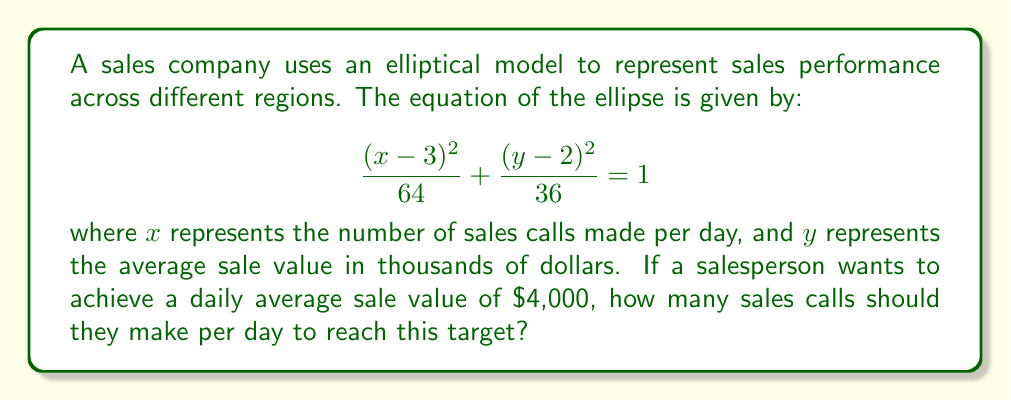Provide a solution to this math problem. Let's approach this step-by-step:

1) We're given the ellipse equation:
   $$\frac{(x-3)^2}{64} + \frac{(y-2)^2}{36} = 1$$

2) We want to find $x$ when $y = 4$ (since $4,000 is represented as 4 in the equation).

3) Substitute $y = 4$ into the equation:
   $$\frac{(x-3)^2}{64} + \frac{(4-2)^2}{36} = 1$$

4) Simplify:
   $$\frac{(x-3)^2}{64} + \frac{4}{36} = 1$$

5) Solve for $(x-3)^2$:
   $$\frac{(x-3)^2}{64} = 1 - \frac{4}{36} = \frac{32}{36} = \frac{8}{9}$$

6) Multiply both sides by 64:
   $$(x-3)^2 = \frac{8}{9} \cdot 64 = \frac{512}{9}$$

7) Take the square root of both sides:
   $$x-3 = \pm\sqrt{\frac{512}{9}} = \pm\frac{16\sqrt{2}}{3}$$

8) Solve for $x$:
   $$x = 3 \pm \frac{16\sqrt{2}}{3}$$

9) Since we're dealing with the number of sales calls, we need the positive solution:
   $$x = 3 + \frac{16\sqrt{2}}{3} \approx 10.54$$

10) Round to the nearest whole number, as we can't make a fractional number of calls.
Answer: 11 sales calls per day 